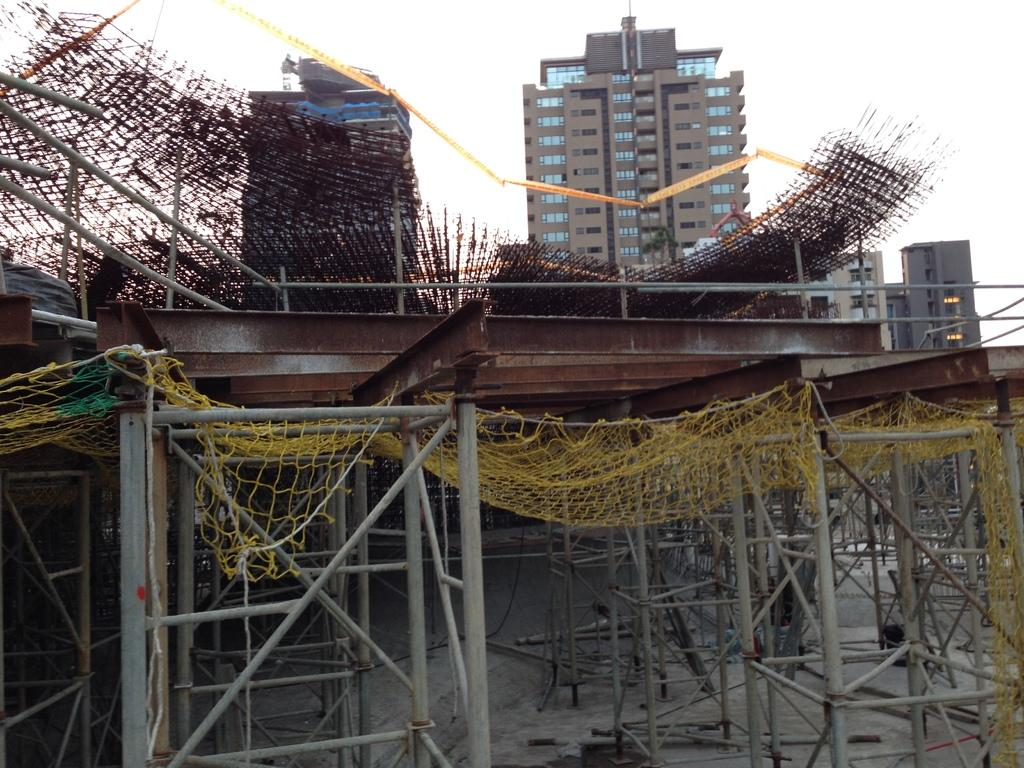What is the main subject in the center of the image? There are buildings in the center of the image. What can be seen at the bottom of the image? Construction material and stands are present at the bottom of the image. What object is visible in the image that is used for catching or holding? There is a net in the image. What is visible in the background of the image? The sky is visible in the background of the image. What type of news can be heard coming from the buildings in the image? There is no indication in the image that any news is being broadcasted or heard from the buildings. 